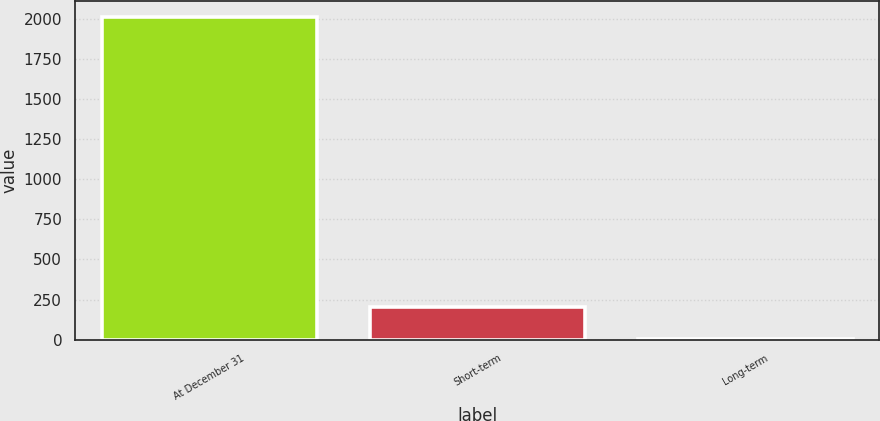Convert chart to OTSL. <chart><loc_0><loc_0><loc_500><loc_500><bar_chart><fcel>At December 31<fcel>Short-term<fcel>Long-term<nl><fcel>2012<fcel>204.04<fcel>3.16<nl></chart> 